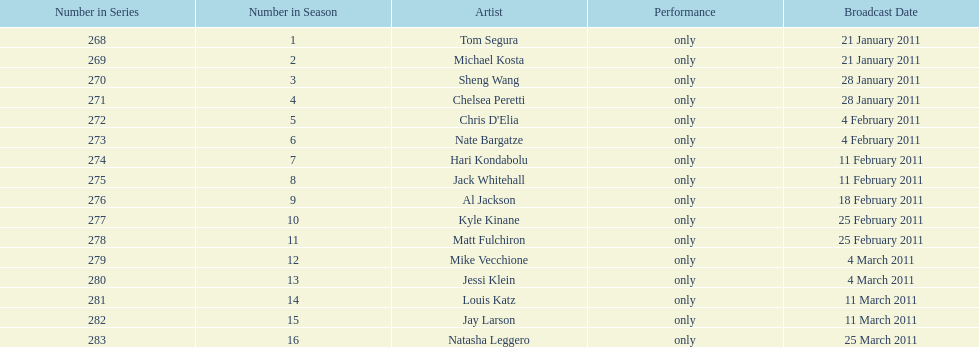Could you parse the entire table as a dict? {'header': ['Number in Series', 'Number in Season', 'Artist', 'Performance', 'Broadcast Date'], 'rows': [['268', '1', 'Tom Segura', 'only', '21 January 2011'], ['269', '2', 'Michael Kosta', 'only', '21 January 2011'], ['270', '3', 'Sheng Wang', 'only', '28 January 2011'], ['271', '4', 'Chelsea Peretti', 'only', '28 January 2011'], ['272', '5', "Chris D'Elia", 'only', '4 February 2011'], ['273', '6', 'Nate Bargatze', 'only', '4 February 2011'], ['274', '7', 'Hari Kondabolu', 'only', '11 February 2011'], ['275', '8', 'Jack Whitehall', 'only', '11 February 2011'], ['276', '9', 'Al Jackson', 'only', '18 February 2011'], ['277', '10', 'Kyle Kinane', 'only', '25 February 2011'], ['278', '11', 'Matt Fulchiron', 'only', '25 February 2011'], ['279', '12', 'Mike Vecchione', 'only', '4 March 2011'], ['280', '13', 'Jessi Klein', 'only', '4 March 2011'], ['281', '14', 'Louis Katz', 'only', '11 March 2011'], ['282', '15', 'Jay Larson', 'only', '11 March 2011'], ['283', '16', 'Natasha Leggero', 'only', '25 March 2011']]} How many comedians made their only appearance on comedy central presents in season 15? 16. 